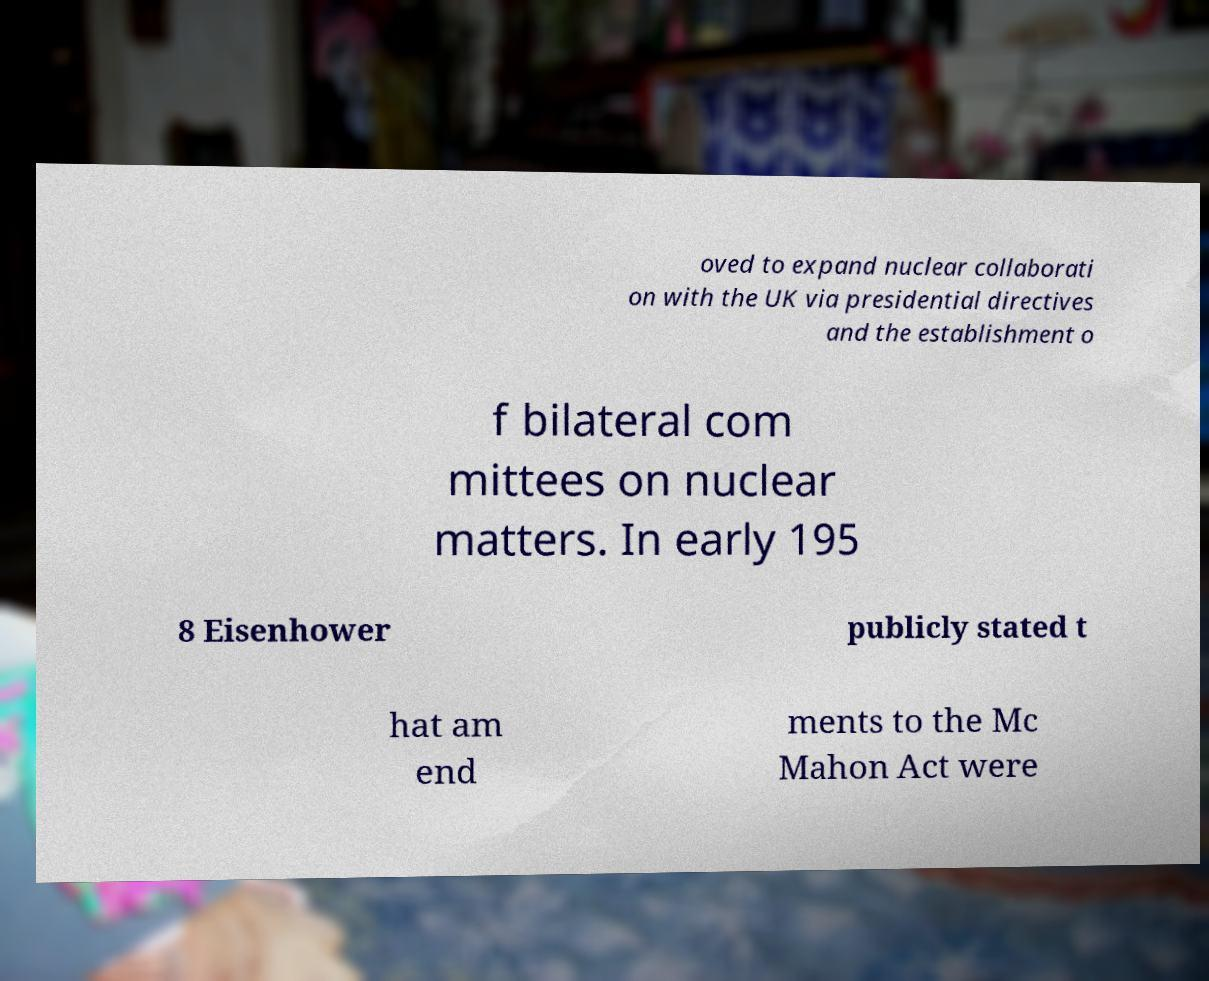Can you accurately transcribe the text from the provided image for me? oved to expand nuclear collaborati on with the UK via presidential directives and the establishment o f bilateral com mittees on nuclear matters. In early 195 8 Eisenhower publicly stated t hat am end ments to the Mc Mahon Act were 